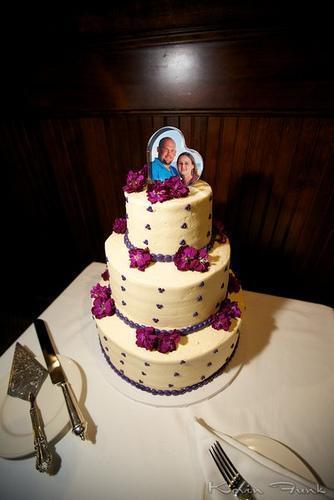How many utensils are in the table?
Give a very brief answer. 3. How many tiers on the cake?
Give a very brief answer. 3. How many cakes can be seen?
Give a very brief answer. 2. 